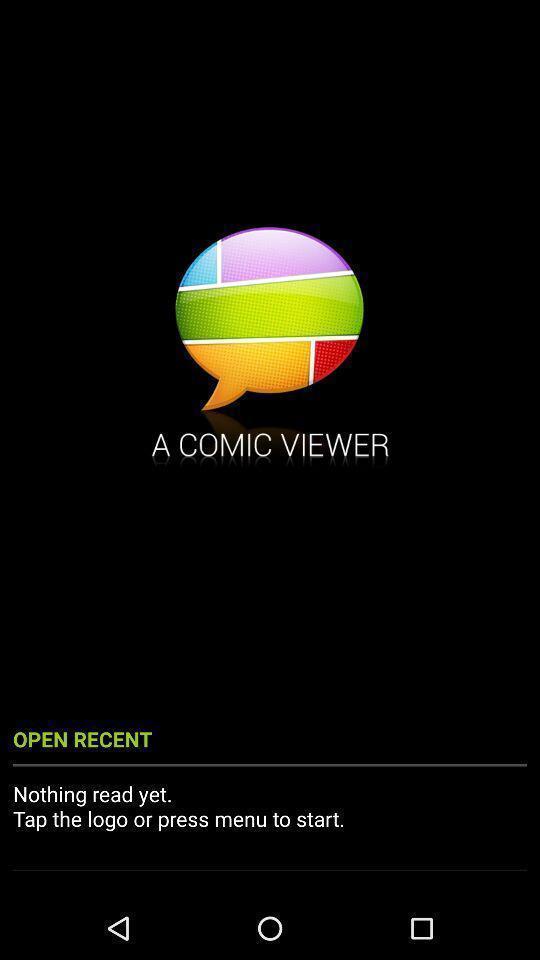Explain what's happening in this screen capture. Welcome page for a comic book reader. 